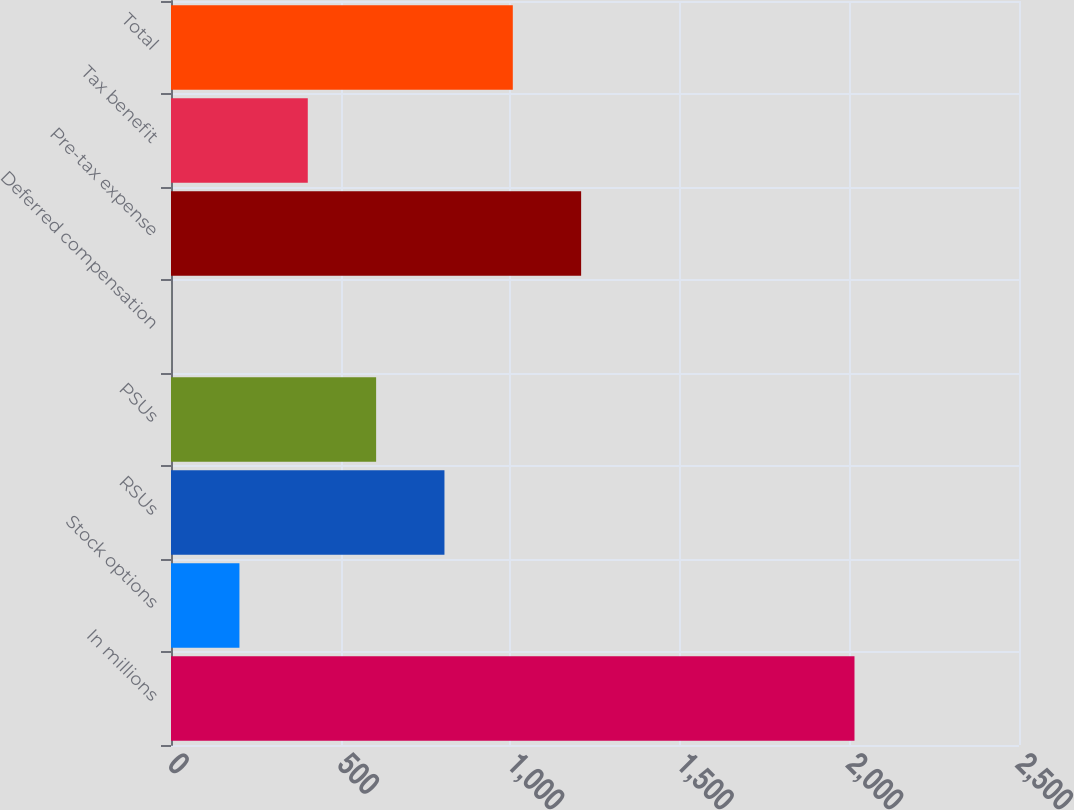Convert chart. <chart><loc_0><loc_0><loc_500><loc_500><bar_chart><fcel>In millions<fcel>Stock options<fcel>RSUs<fcel>PSUs<fcel>Deferred compensation<fcel>Pre-tax expense<fcel>Tax benefit<fcel>Total<nl><fcel>2015<fcel>201.77<fcel>806.18<fcel>604.71<fcel>0.3<fcel>1209.12<fcel>403.24<fcel>1007.65<nl></chart> 